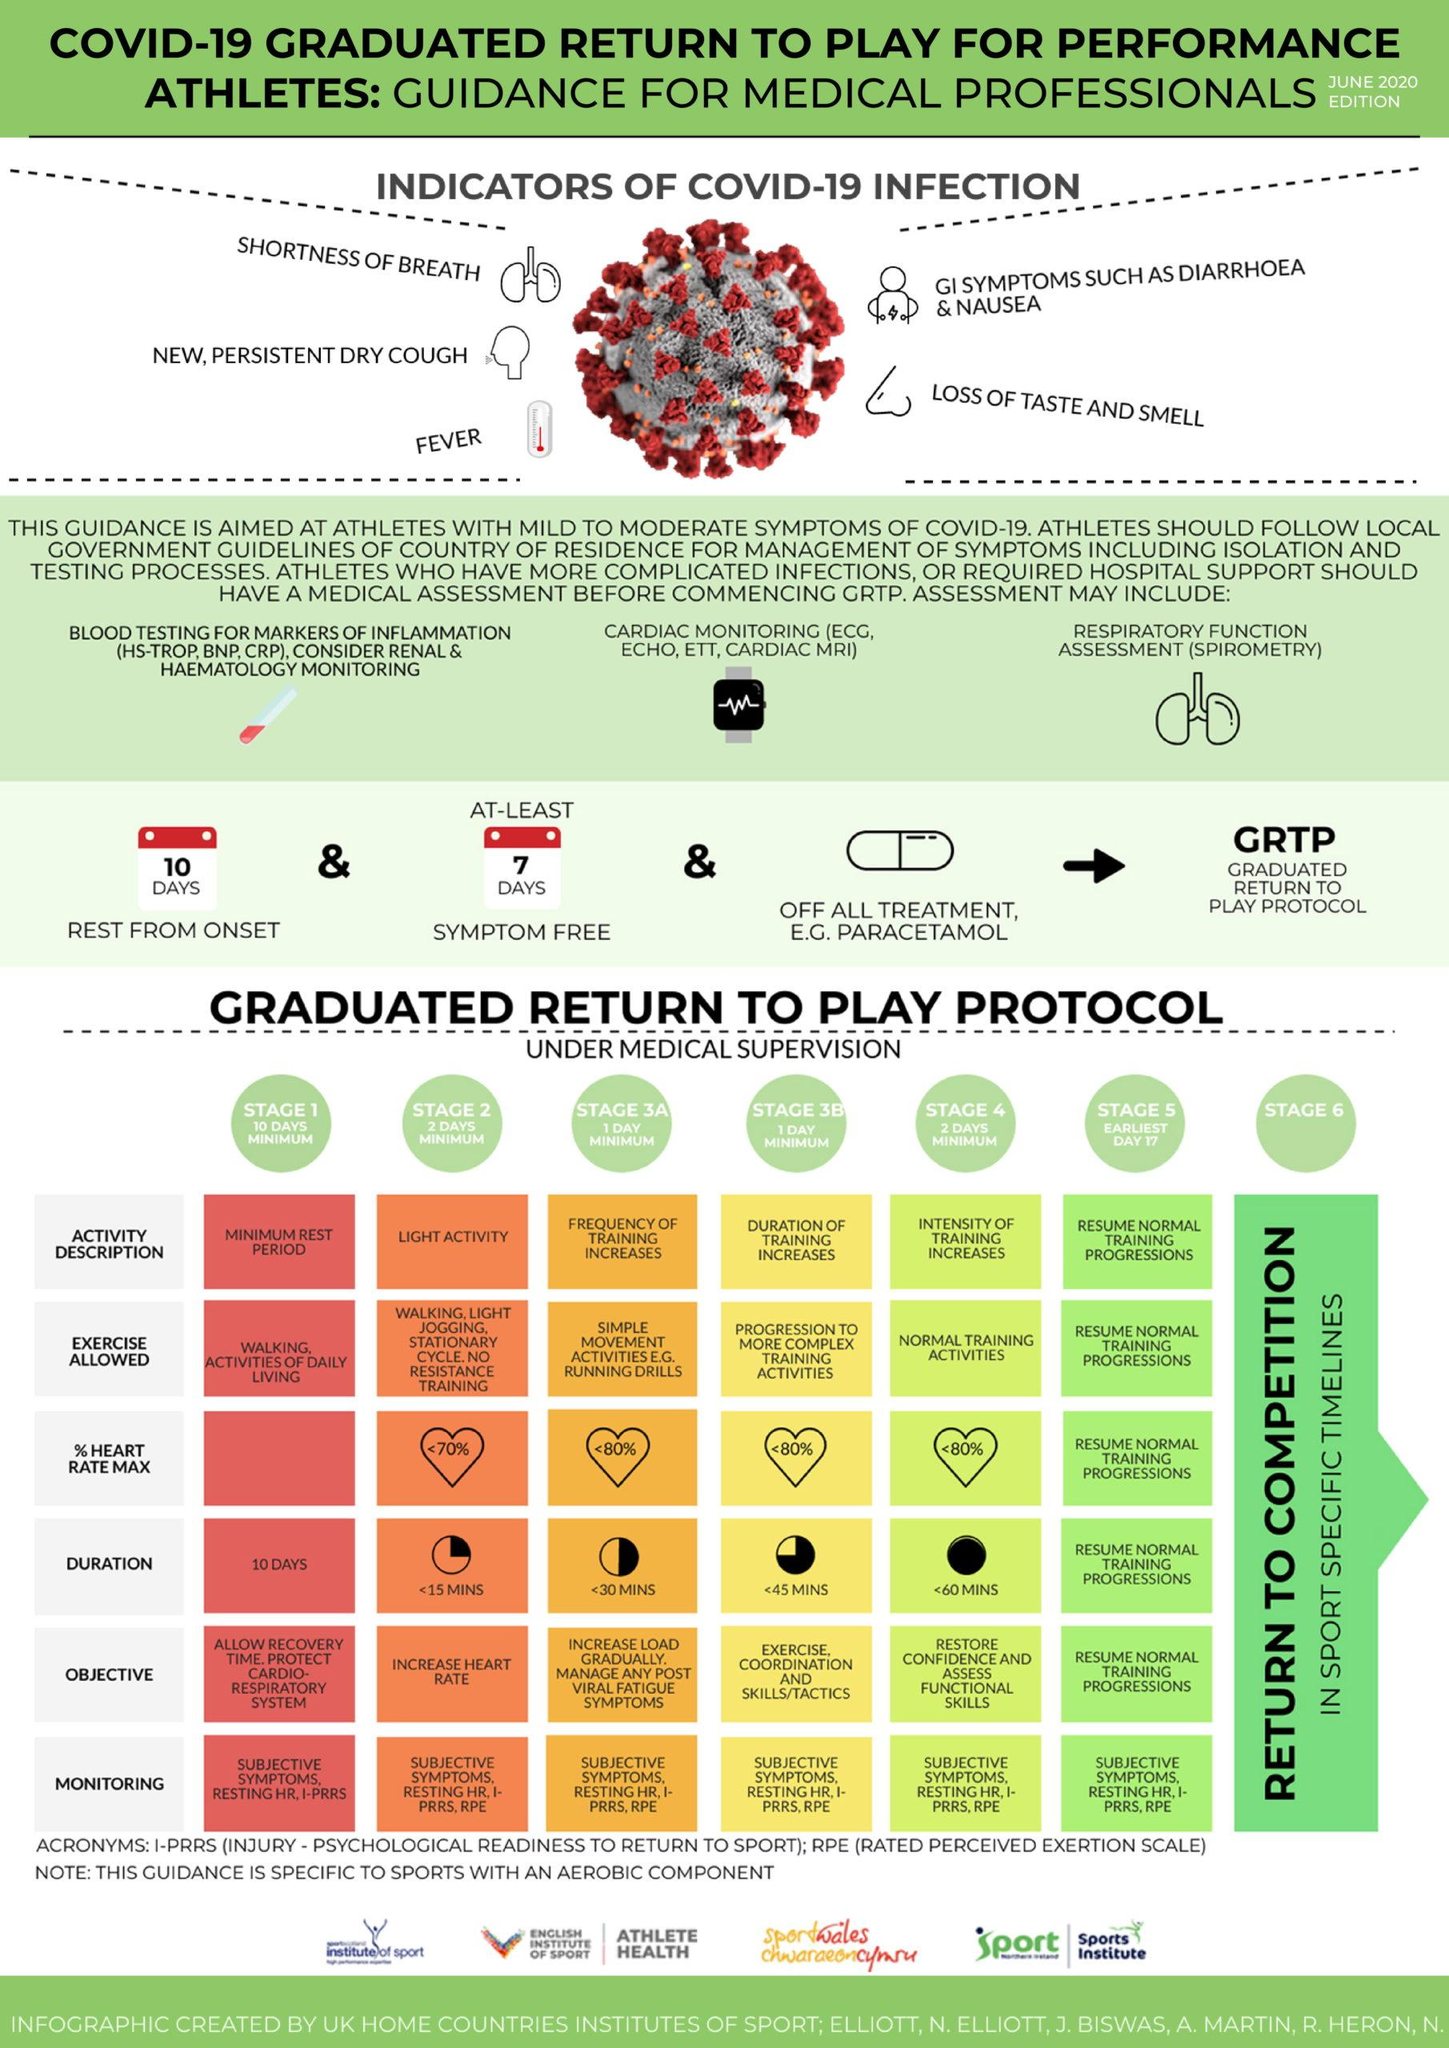Give some essential details in this illustration. The third medical assessment mentioned in the infographic is Respiratory Function Assessment (Spirometry). There are three different medical assessments listed for individuals with complicated infections. The Stage 4 supervision is a minimum of 2 days. The person will not have any indication of COVID-19 for 7 days. The stage of medical supervision where the graduate is free to return to normal life is stage 6. 